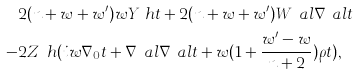<formula> <loc_0><loc_0><loc_500><loc_500>& 2 ( n + w + w ^ { \prime } ) w Y _ { \P } h t + 2 ( n + w + w ^ { \prime } ) W _ { \P } ^ { \ } a l \nabla _ { \ } a l t \\ - & 2 Z _ { \P } h ( i w \nabla _ { 0 } t + \nabla ^ { \ } a l \nabla _ { \ } a l t + w ( 1 + \frac { w ^ { \prime } - w } { n + 2 } ) \rho t ) ,</formula> 